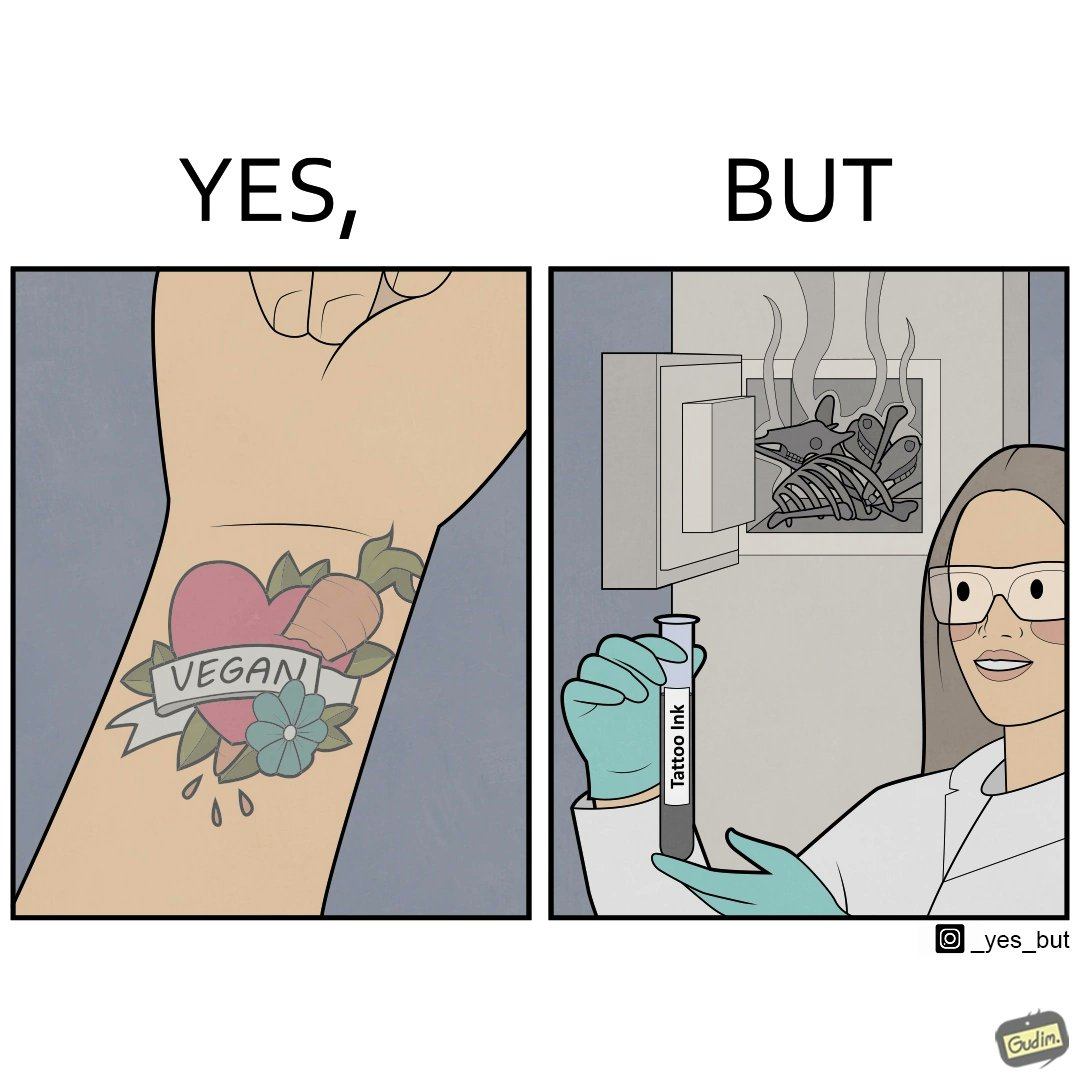Is there satirical content in this image? Yes, this image is satirical. 